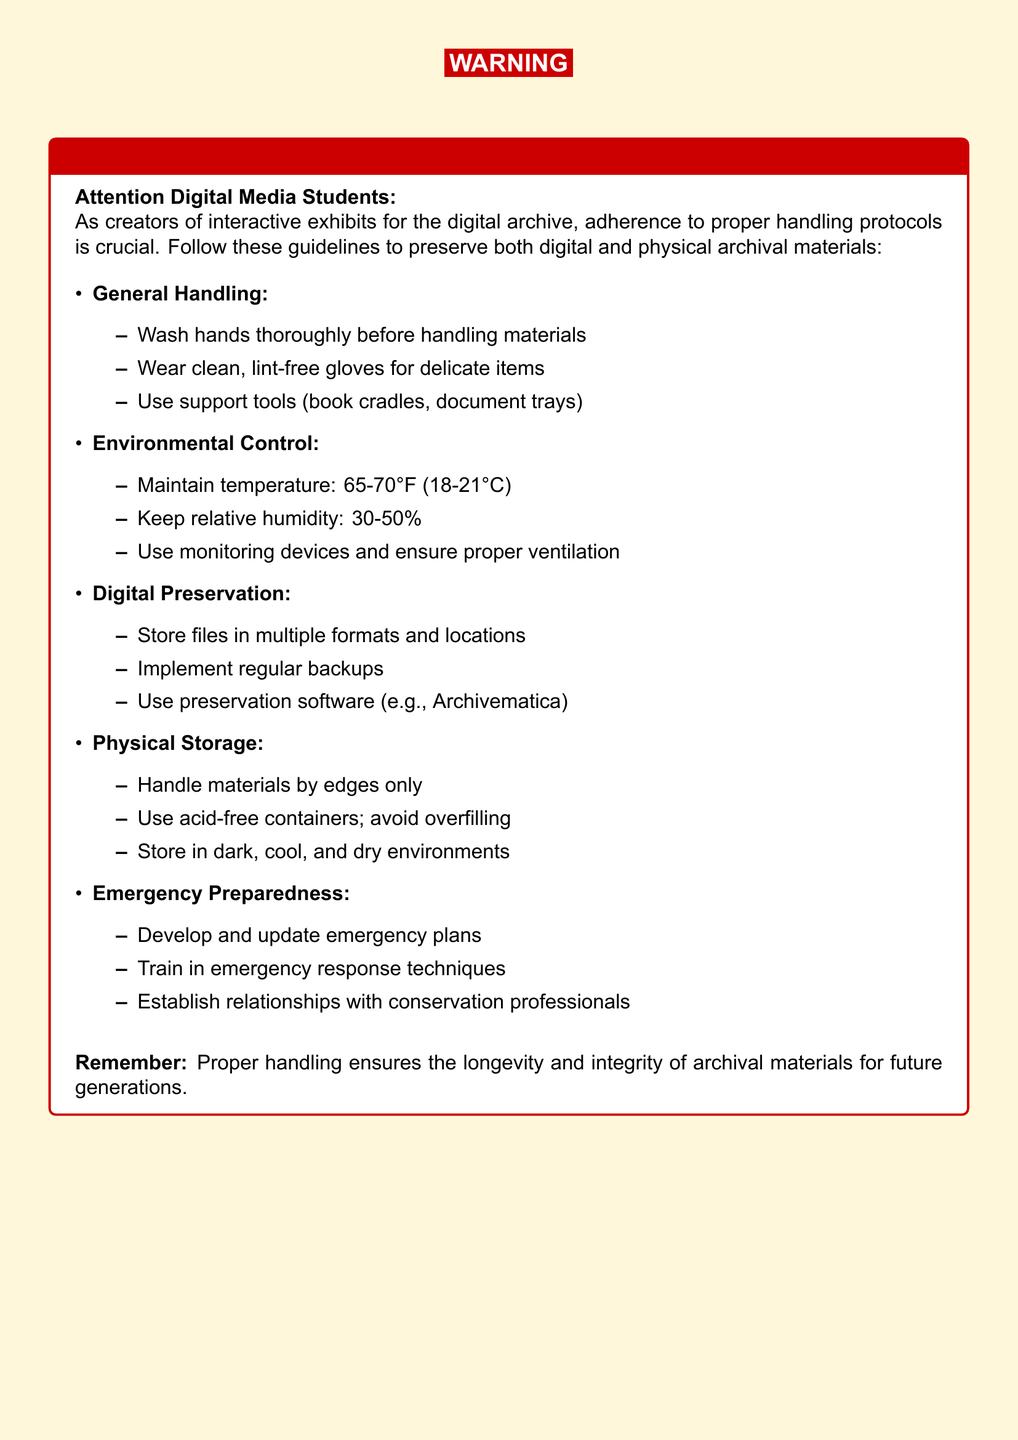What is the temperature range for archival materials? The optimal temperature range for archival materials is listed in the document as 65-70°F (18-21°C).
Answer: 65-70°F (18-21°C) What should you wear when handling delicate items? The document specifies to wear clean, lint-free gloves when handling delicate items.
Answer: Clean, lint-free gloves What is the acceptable relative humidity for archival materials? The acceptable relative humidity for archival materials is stated as 30-50%.
Answer: 30-50% What type of containers should be used for physical storage? The document indicates to use acid-free containers for physical storage.
Answer: Acid-free containers How often should backups be implemented for digital preservation? The document states that regular backups should be implemented for digital preservation, indicating frequency without specifying an exact number.
Answer: Regularly What action should be taken before handling archival materials? It is recommended to wash hands thoroughly before handling materials as stated in the document.
Answer: Wash hands What is one emergency preparedness action mentioned? The document lists developing and updating emergency plans as one action for emergency preparedness.
Answer: Develop emergency plans What should be avoided when filling storage containers? The document advises to avoid overfilling storage containers.
Answer: Overfilling Who should be established relationships with for emergency response? The document suggests establishing relationships with conservation professionals for emergency response.
Answer: Conservation professionals 